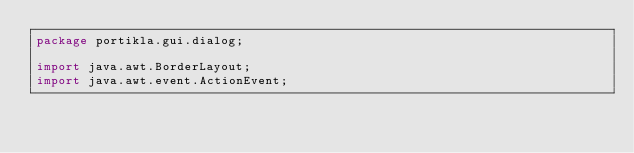Convert code to text. <code><loc_0><loc_0><loc_500><loc_500><_Java_>package portikla.gui.dialog;

import java.awt.BorderLayout;
import java.awt.event.ActionEvent;</code> 